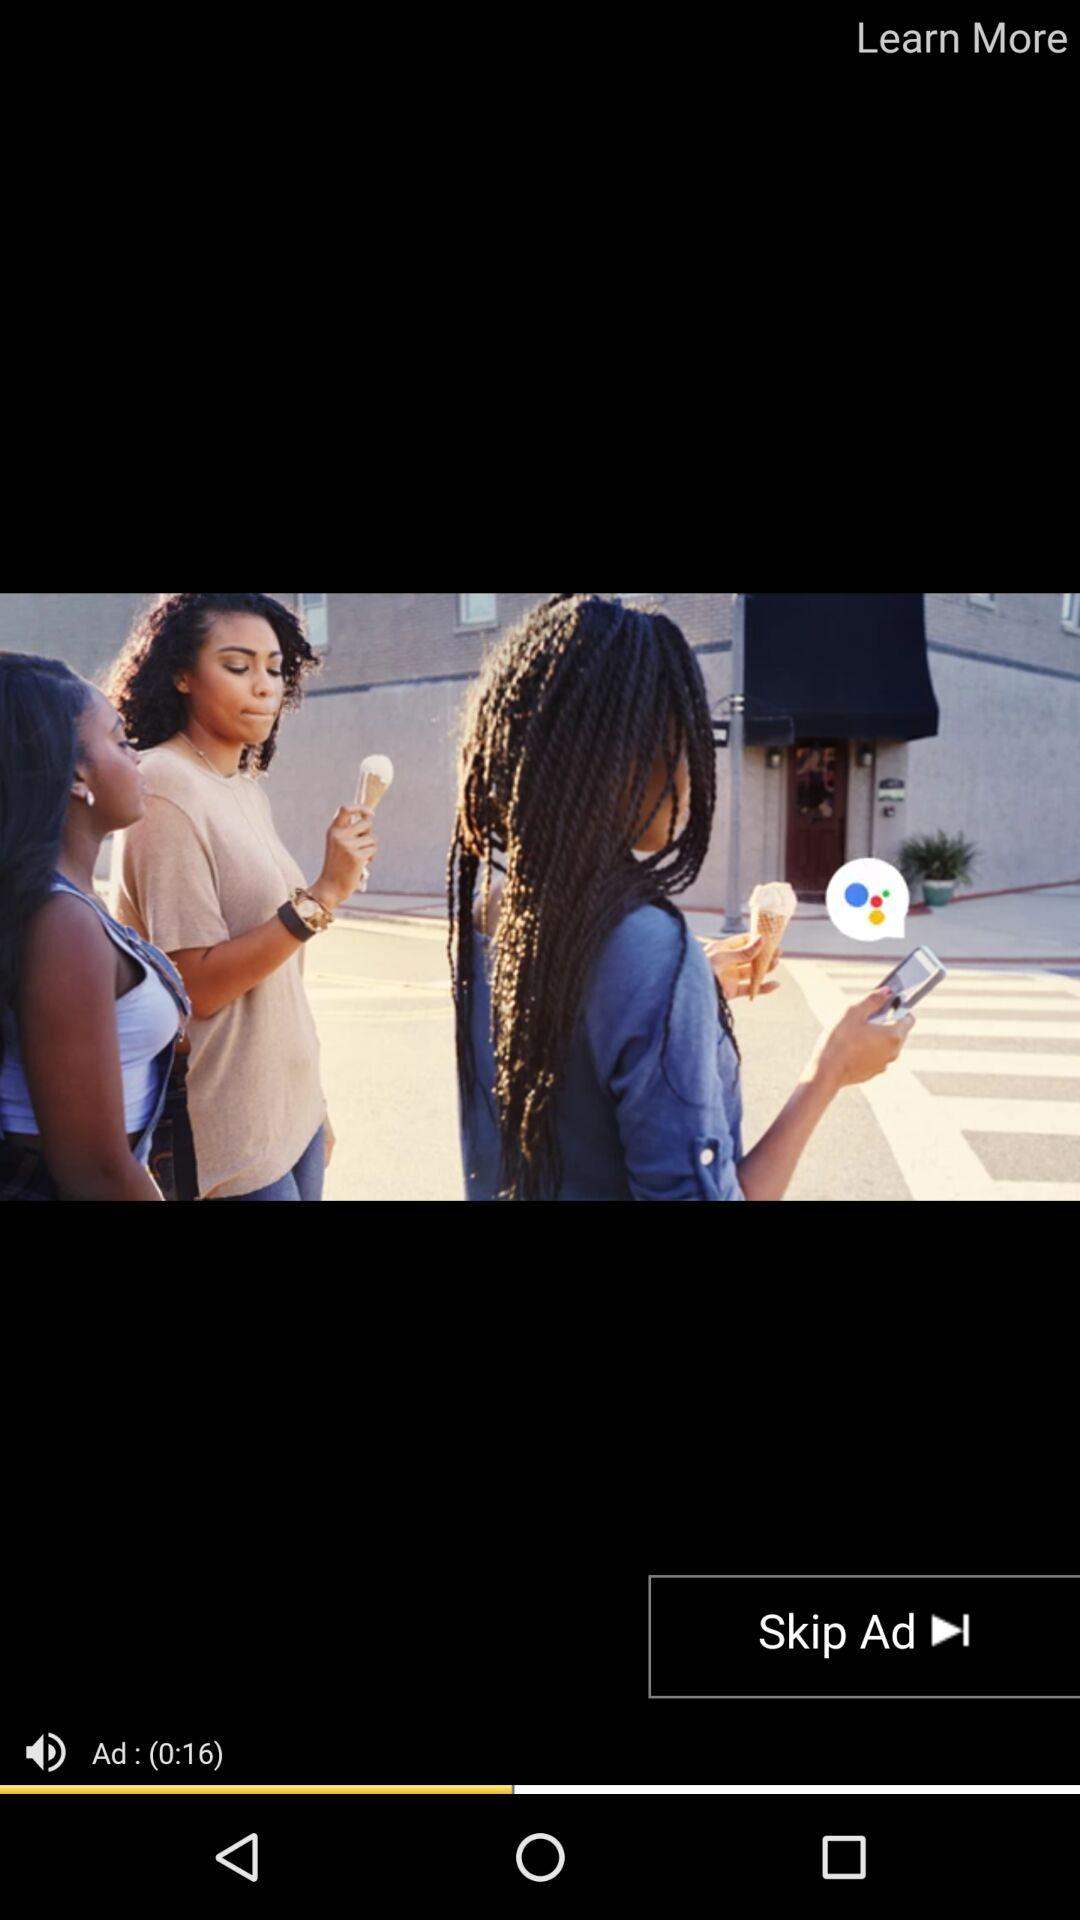How many seconds is the ad?
Answer the question using a single word or phrase. 16 